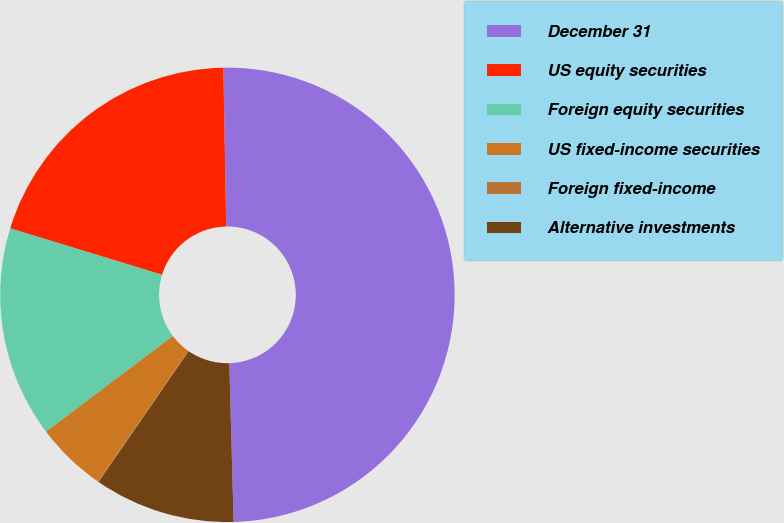<chart> <loc_0><loc_0><loc_500><loc_500><pie_chart><fcel>December 31<fcel>US equity securities<fcel>Foreign equity securities<fcel>US fixed-income securities<fcel>Foreign fixed-income<fcel>Alternative investments<nl><fcel>49.85%<fcel>19.99%<fcel>15.01%<fcel>5.05%<fcel>0.07%<fcel>10.03%<nl></chart> 